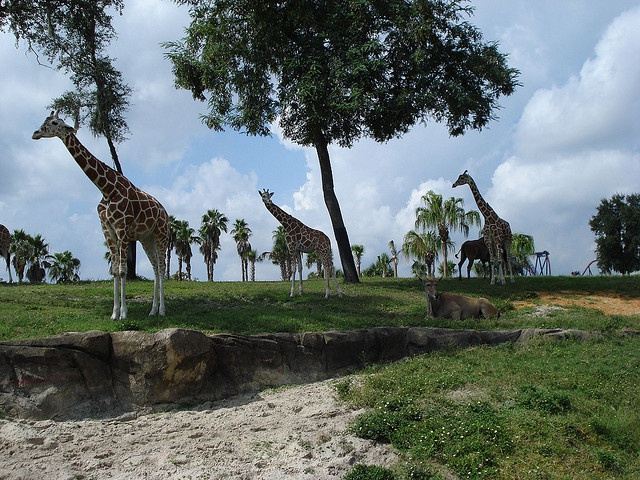Describe the objects in this image and their specific colors. I can see giraffe in black, gray, darkgreen, and darkgray tones, giraffe in black, gray, darkgreen, and darkgray tones, giraffe in black, gray, and lightblue tones, and giraffe in black, gray, and darkgray tones in this image. 